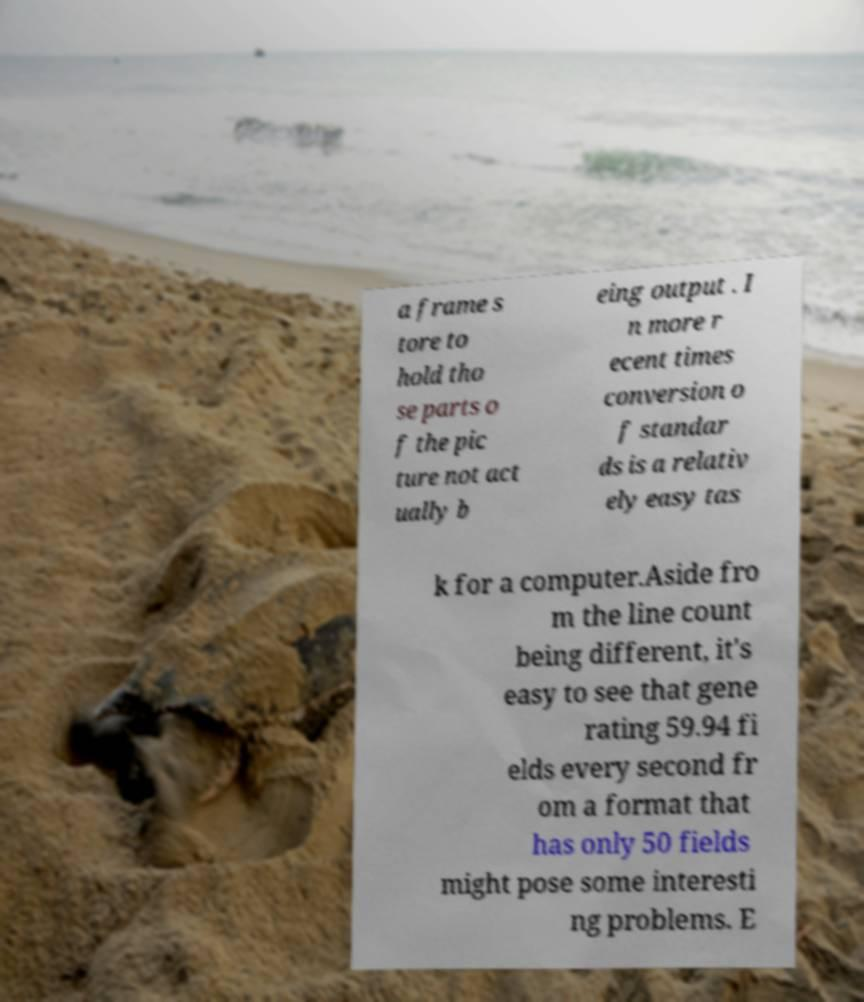Can you accurately transcribe the text from the provided image for me? a frame s tore to hold tho se parts o f the pic ture not act ually b eing output . I n more r ecent times conversion o f standar ds is a relativ ely easy tas k for a computer.Aside fro m the line count being different, it's easy to see that gene rating 59.94 fi elds every second fr om a format that has only 50 fields might pose some interesti ng problems. E 